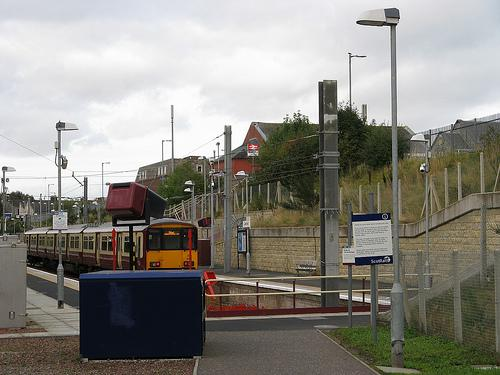What type of train is shown in the image? A passenger train. Explain the atmosphere depicted in the image by describing the sky. The sky is full of clouds, creating a somewhat overcast atmosphere. Can you describe the smaller objects on the ground in the image? There are brown rocks, a patch of short grass, a gray box, and a bin up front. Can you tell me the activities happening in this image surrounding the train? A train is driving, with its front being orange and having front windows. What color is the train in the image? The train is orange, black, and yellow. List the colors of the objects found in the image. Orange, black, yellow, white, red, blue, gray, brown, and green. What is the color of the sign found in the image? The sign is blue, white, black, and white. How many different colors are mentioned in the object captions? 9 colors. Mention the main elements in the image and their colors. Train (orange, black, and yellow), railing (white and red), sign (blue, white, black, and white), sky (cloudy), ground (brown rocks, short grass). How would you describe the scenery around the train stop? There is a hill full of weeds, brown rocks on the ground, a patch of short grass, and a cloudy sky. What activity is the train engaging in? The train is driving. Imagine and describe a story taking place in the setting shown in the image. On a cloudy day in the city, a passenger train arrives at the train stop, and travelers eagerly wait to board, surrounded by a landscape full of rocks and a hill of weeds. Do the clouds cover most of the sky in the image? Yes Describe the sign in the image. The sign is blue and white. Are the front windows of the train green and square-shaped? No, it's not mentioned in the image. Which of the following colors best describe the train front in the image? a) Orange and black b) Blue and white c) Red and green  a) Orange and black Detail the objects seen in the image: the train, the ground, and the sky. The train is a passenger train with the front orange and black, ground has brown rocks and short grass, and the sky is full of clouds. Is the railing in the transit area colored green and blue? The railing is not colored green and blue; it is described as "the railing is white and red" (X:230 Y:273 Width:136 Height:136). The colors in the instruction do not match the actual colors of the object. Which color is the roof on the building? Not mentioned in the information given. In a descriptive manner, narrate what colors represent the sky and train in the image. The sky is painted with clouds, while the train is a vibrant fusion of orange and black. Is there a large pink balloon floating above the power line in the sky? There is no mention of a pink balloon in the information provided. The mention of a power line in the sky is given (X:16 Y:145 Width:25 Height:25), but there is no mention of a balloon or any other object above it. What is the color of the box present in the image? gray Is there a pole visible in the sky in the image? Yes, there is a pole in the sky. What type of area is shown in the image with coordinates (62, 112)? transit area Can you identify an event happening in the image? Train arriving at the train stop. In the image, is the train a cargo train or a passenger train? passenger train  What kind of grass is seen in the image? A patch of short grass. Is the sky behind the train stop mostly clear with no clouds? The sky is not mostly clear as it is described as "the sky is full of clouds" (X:0 Y:2 Width:494 Height:494), which does not match the instruction. What item can be seen up front in the image? A bin can be seen up front. What objects can be found on the right side of the image? The buildings can be found on the right side. Describe the railing in the image. The railing is white and red. What type of power line is seen in the sky? A power line is in the sky, but its specific type is not mentioned. 